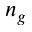<formula> <loc_0><loc_0><loc_500><loc_500>n _ { g }</formula> 